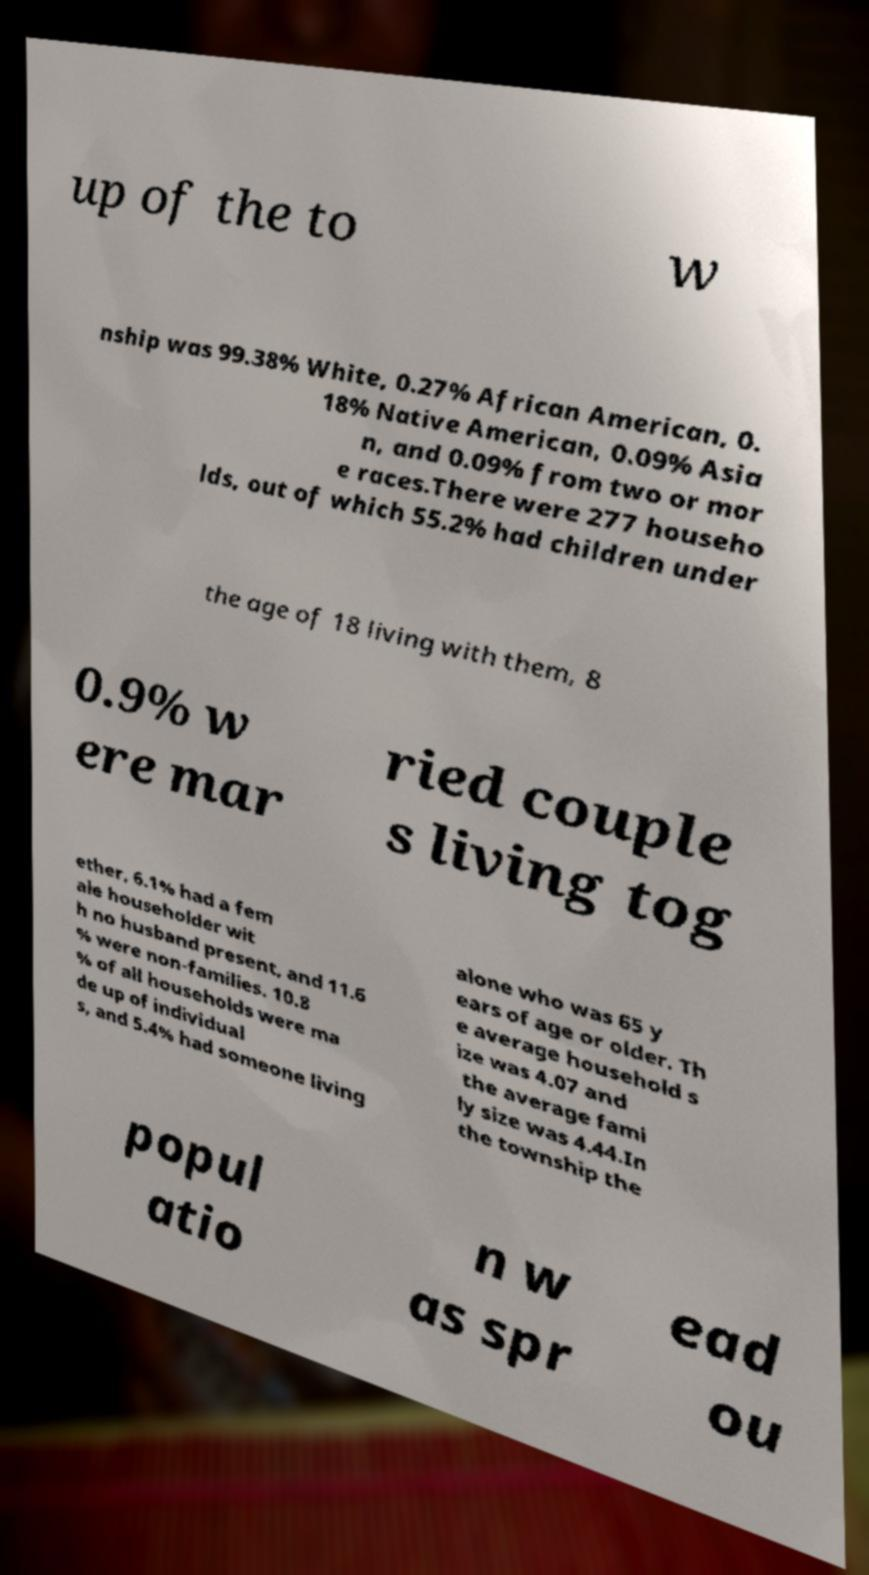Can you read and provide the text displayed in the image?This photo seems to have some interesting text. Can you extract and type it out for me? up of the to w nship was 99.38% White, 0.27% African American, 0. 18% Native American, 0.09% Asia n, and 0.09% from two or mor e races.There were 277 househo lds, out of which 55.2% had children under the age of 18 living with them, 8 0.9% w ere mar ried couple s living tog ether, 6.1% had a fem ale householder wit h no husband present, and 11.6 % were non-families. 10.8 % of all households were ma de up of individual s, and 5.4% had someone living alone who was 65 y ears of age or older. Th e average household s ize was 4.07 and the average fami ly size was 4.44.In the township the popul atio n w as spr ead ou 